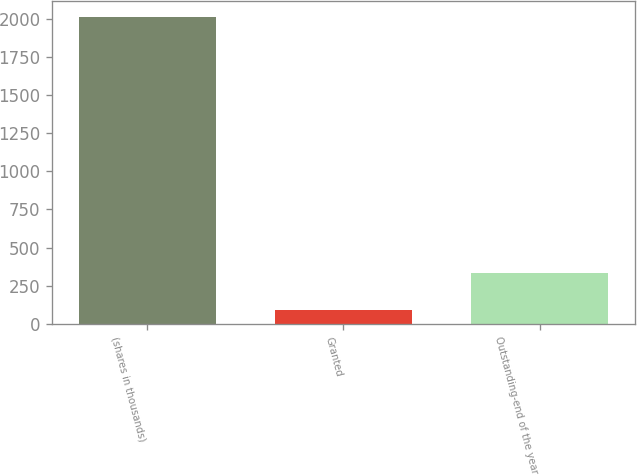<chart> <loc_0><loc_0><loc_500><loc_500><bar_chart><fcel>(shares in thousands)<fcel>Granted<fcel>Outstanding-end of the year<nl><fcel>2013<fcel>94<fcel>334<nl></chart> 